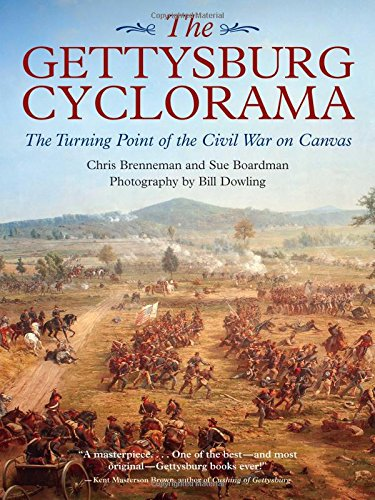Who wrote this book? Chris Brenneman co-authored 'The Gettysburg Cyclorama' book. He collaborated with Sue Boardman to present an in-depth pictorial and historical account of the Battle of Gettysburg as depicted on canvas. 